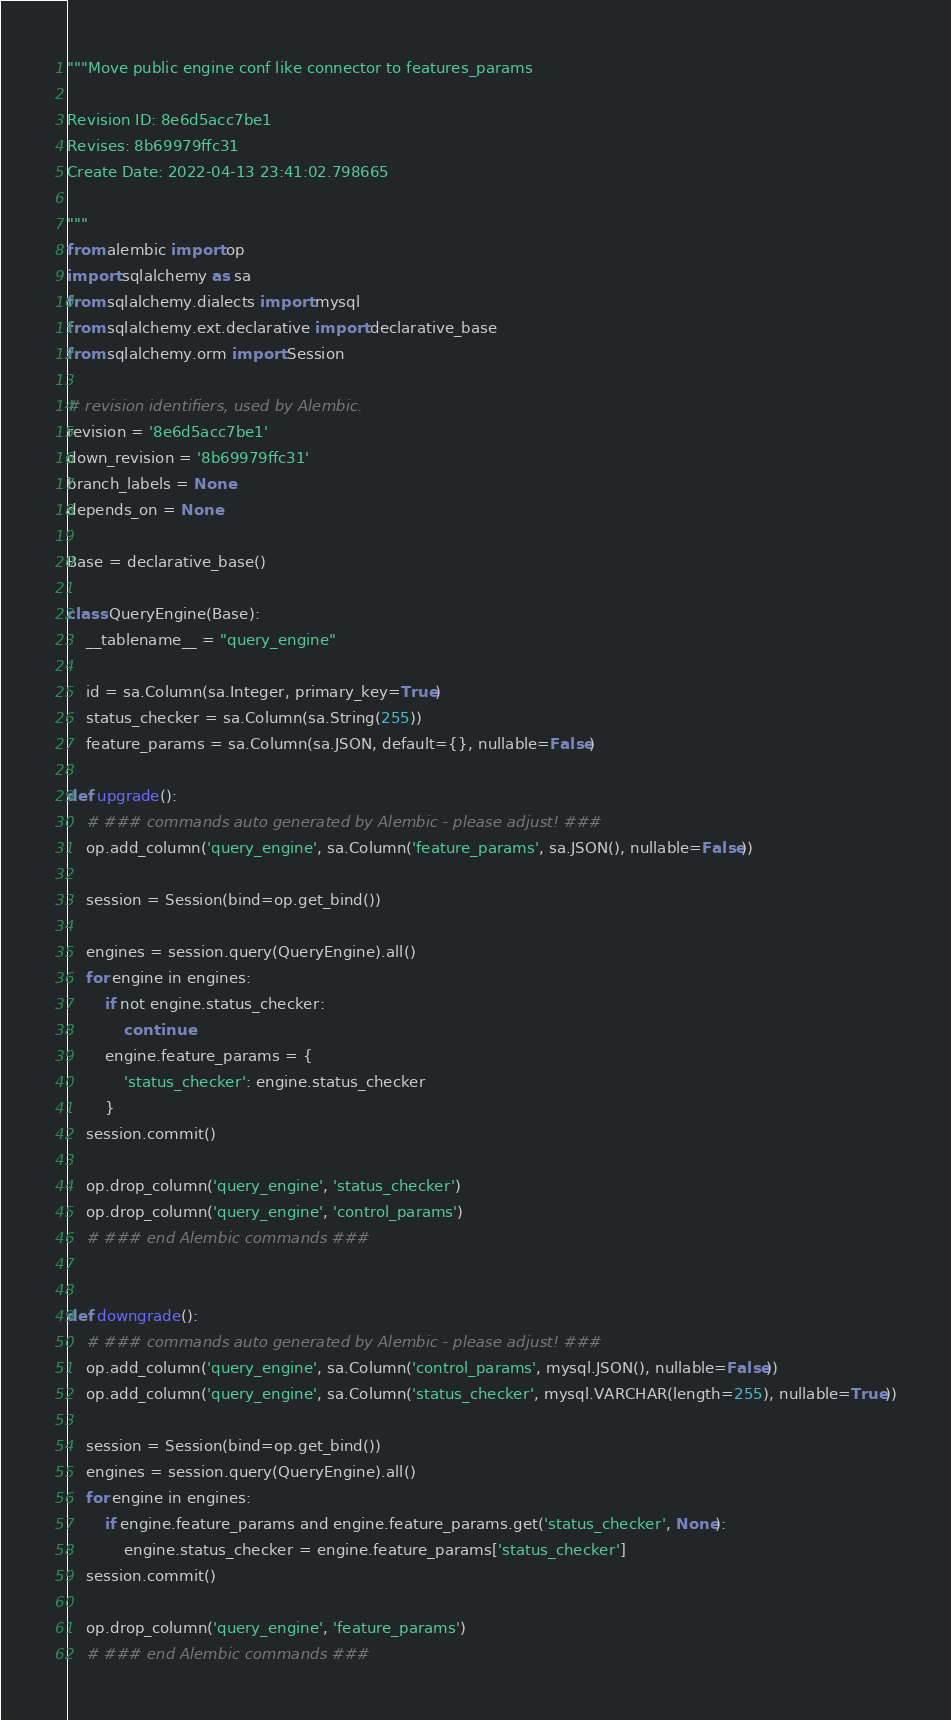<code> <loc_0><loc_0><loc_500><loc_500><_Python_>"""Move public engine conf like connector to features_params

Revision ID: 8e6d5acc7be1
Revises: 8b69979ffc31
Create Date: 2022-04-13 23:41:02.798665

"""
from alembic import op
import sqlalchemy as sa
from sqlalchemy.dialects import mysql
from sqlalchemy.ext.declarative import declarative_base
from sqlalchemy.orm import Session

# revision identifiers, used by Alembic.
revision = '8e6d5acc7be1'
down_revision = '8b69979ffc31'
branch_labels = None
depends_on = None

Base = declarative_base()

class QueryEngine(Base):
    __tablename__ = "query_engine"

    id = sa.Column(sa.Integer, primary_key=True)
    status_checker = sa.Column(sa.String(255))
    feature_params = sa.Column(sa.JSON, default={}, nullable=False)

def upgrade():
    # ### commands auto generated by Alembic - please adjust! ###
    op.add_column('query_engine', sa.Column('feature_params', sa.JSON(), nullable=False))

    session = Session(bind=op.get_bind())

    engines = session.query(QueryEngine).all()
    for engine in engines:
        if not engine.status_checker:
            continue
        engine.feature_params = {
            'status_checker': engine.status_checker
        }
    session.commit()

    op.drop_column('query_engine', 'status_checker')
    op.drop_column('query_engine', 'control_params')
    # ### end Alembic commands ###


def downgrade():
    # ### commands auto generated by Alembic - please adjust! ###
    op.add_column('query_engine', sa.Column('control_params', mysql.JSON(), nullable=False))
    op.add_column('query_engine', sa.Column('status_checker', mysql.VARCHAR(length=255), nullable=True))

    session = Session(bind=op.get_bind())
    engines = session.query(QueryEngine).all()
    for engine in engines:
        if engine.feature_params and engine.feature_params.get('status_checker', None):
            engine.status_checker = engine.feature_params['status_checker']
    session.commit()

    op.drop_column('query_engine', 'feature_params')
    # ### end Alembic commands ###
</code> 